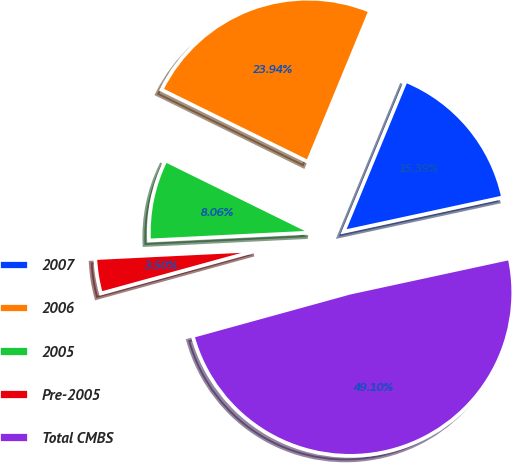Convert chart to OTSL. <chart><loc_0><loc_0><loc_500><loc_500><pie_chart><fcel>2007<fcel>2006<fcel>2005<fcel>Pre-2005<fcel>Total CMBS<nl><fcel>15.39%<fcel>23.94%<fcel>8.06%<fcel>3.5%<fcel>49.1%<nl></chart> 